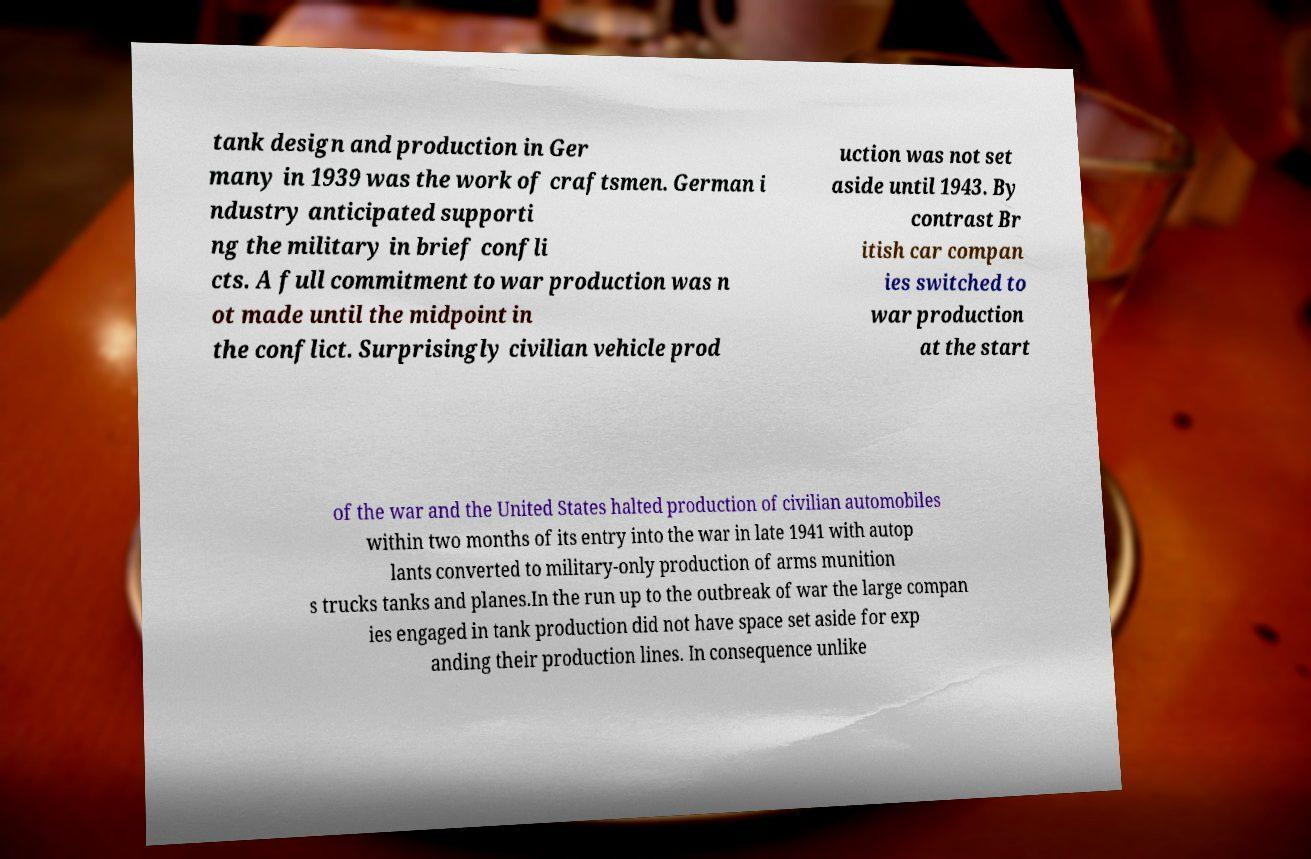Can you read and provide the text displayed in the image?This photo seems to have some interesting text. Can you extract and type it out for me? tank design and production in Ger many in 1939 was the work of craftsmen. German i ndustry anticipated supporti ng the military in brief confli cts. A full commitment to war production was n ot made until the midpoint in the conflict. Surprisingly civilian vehicle prod uction was not set aside until 1943. By contrast Br itish car compan ies switched to war production at the start of the war and the United States halted production of civilian automobiles within two months of its entry into the war in late 1941 with autop lants converted to military-only production of arms munition s trucks tanks and planes.In the run up to the outbreak of war the large compan ies engaged in tank production did not have space set aside for exp anding their production lines. In consequence unlike 